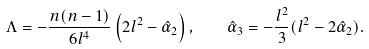<formula> <loc_0><loc_0><loc_500><loc_500>\Lambda = - \frac { n ( n - 1 ) } { 6 l ^ { 4 } } \left ( 2 l ^ { 2 } - \hat { \alpha } _ { 2 } \right ) , \quad \hat { \alpha } _ { 3 } = - \frac { l ^ { 2 } } { 3 } ( l ^ { 2 } - 2 \hat { \alpha } _ { 2 } ) .</formula> 